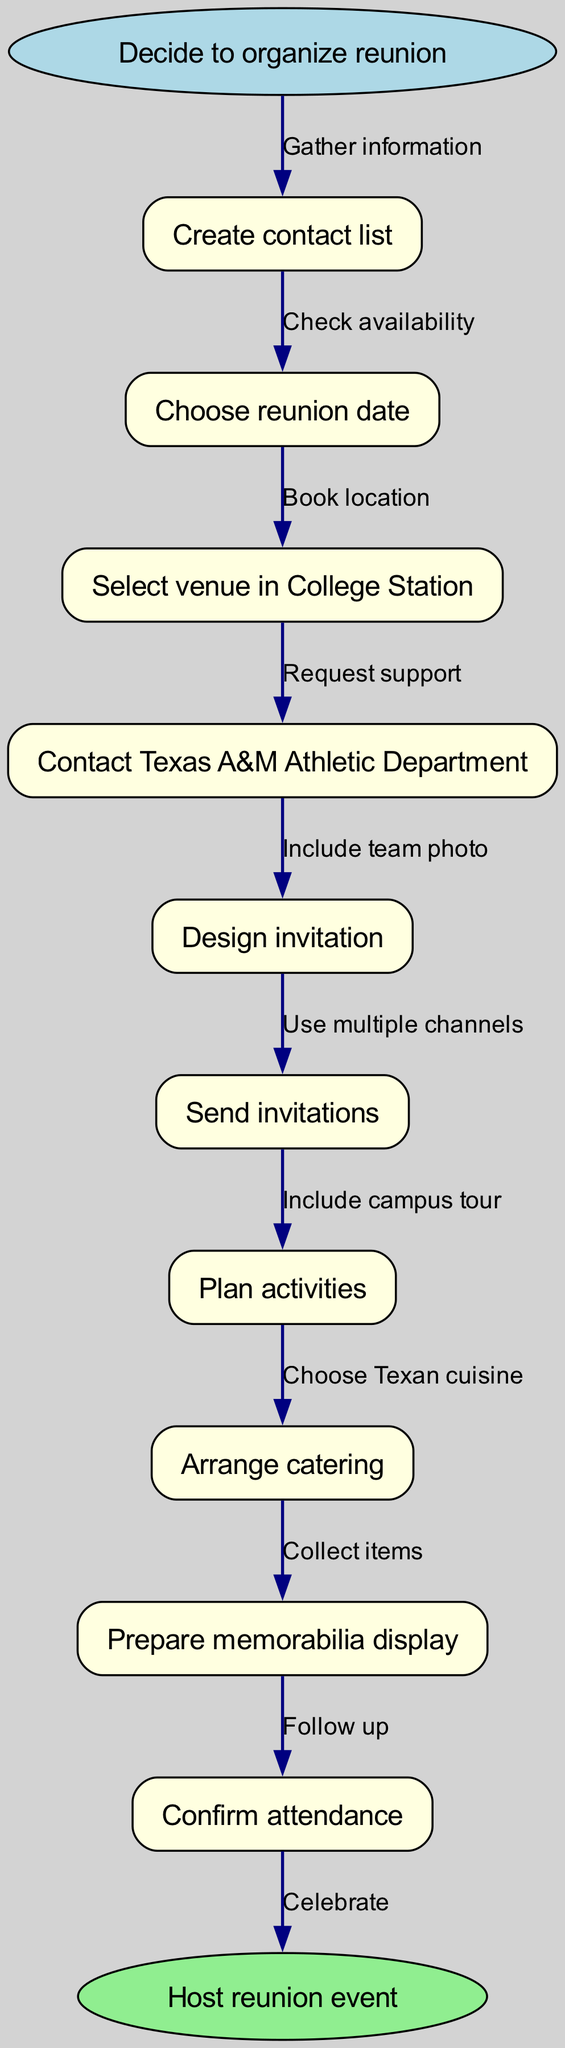What is the starting step for organizing the reunion? The diagram indicates that the starting step is the "Decide to organize reunion" node. This is the initial action before progressing to further steps.
Answer: Decide to organize reunion How many steps are there in the process? By counting the nodes listed in the steps section of the diagram, we find there are ten distinct steps from creating the contact list to confirming attendance.
Answer: Ten What is the last step before hosting the reunion event? According to the flow chart, the final action that occurs right before hosting the reunion is to confirm attendance, meaning this is the last operational step before the culmination of the event.
Answer: Confirm attendance What should be included in the design of the invitation? The diagram specifies that the invitation design needs to include a team photo as part of its content, indicating what kind of imagery is important for its visual appeal.
Answer: Team photo What is the required action after selecting a venue? The edge leading from "Select venue in College Station" clearly states that the subsequent action is to "Book location," indicating that securing the venue follows selection.
Answer: Book location Which step involves gathering information? The first step listed in the diagram, "Create contact list," is explicitly indicated to involve gathering information about potential attendees, highlighting its importance in the organization process.
Answer: Gather information What type of cuisine should be chosen during the reunion planning? The step labeled "Arrange catering" indicates that the cuisine chosen should be Texan, which reflects the regional heritage and preferences for the event.
Answer: Texan cuisine What is the purpose of contacting the Texas A&M Athletic Department? The diagram specifies that the action of contacting the Texas A&M Athletic Department is to request support, outlining their importance in facilitating the reunion's logistics.
Answer: Request support How should invitations be sent out? The flow chart suggests using multiple channels to send invitations, emphasizing the strategy of reaching out to attendees through various means to ensure maximum participation.
Answer: Use multiple channels 